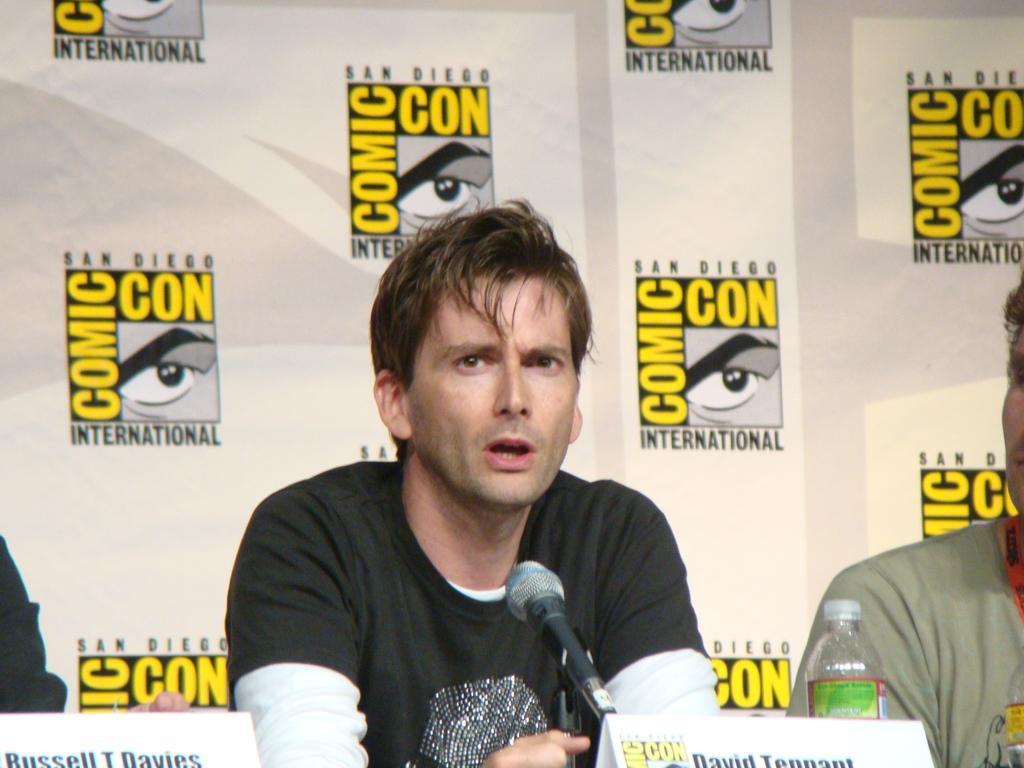How would you summarize this image in a sentence or two? A man with black and white t-shirt is sitting. In front of him there is a mic. He is talking. On the table there is a name board, water bottle. To the right corner there is another person sitting. And behind them there is a big banner. And some logos on it. 